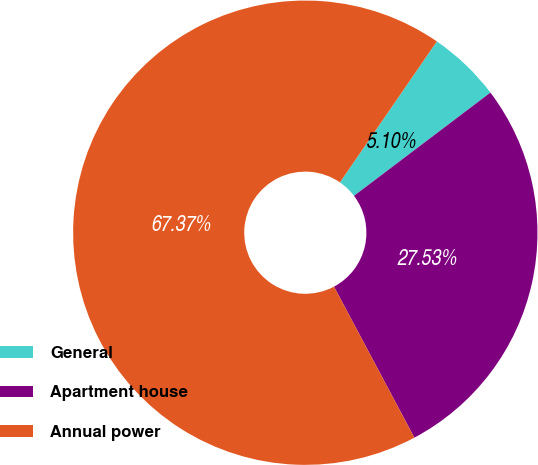Convert chart. <chart><loc_0><loc_0><loc_500><loc_500><pie_chart><fcel>General<fcel>Apartment house<fcel>Annual power<nl><fcel>5.1%<fcel>27.53%<fcel>67.37%<nl></chart> 